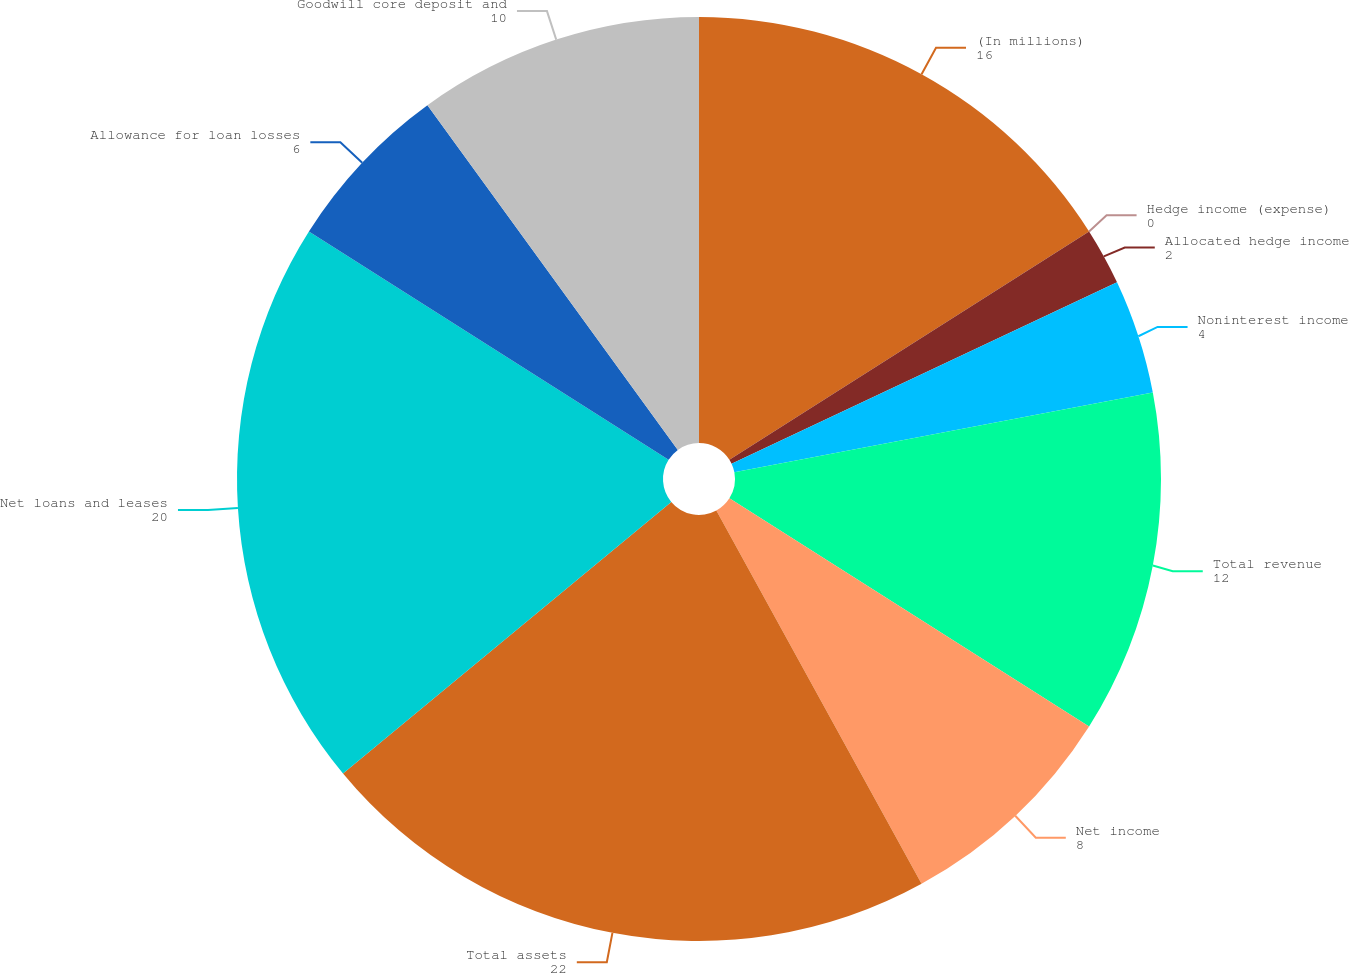Convert chart to OTSL. <chart><loc_0><loc_0><loc_500><loc_500><pie_chart><fcel>(In millions)<fcel>Hedge income (expense)<fcel>Allocated hedge income<fcel>Noninterest income<fcel>Total revenue<fcel>Net income<fcel>Total assets<fcel>Net loans and leases<fcel>Allowance for loan losses<fcel>Goodwill core deposit and<nl><fcel>16.0%<fcel>0.0%<fcel>2.0%<fcel>4.0%<fcel>12.0%<fcel>8.0%<fcel>22.0%<fcel>20.0%<fcel>6.0%<fcel>10.0%<nl></chart> 